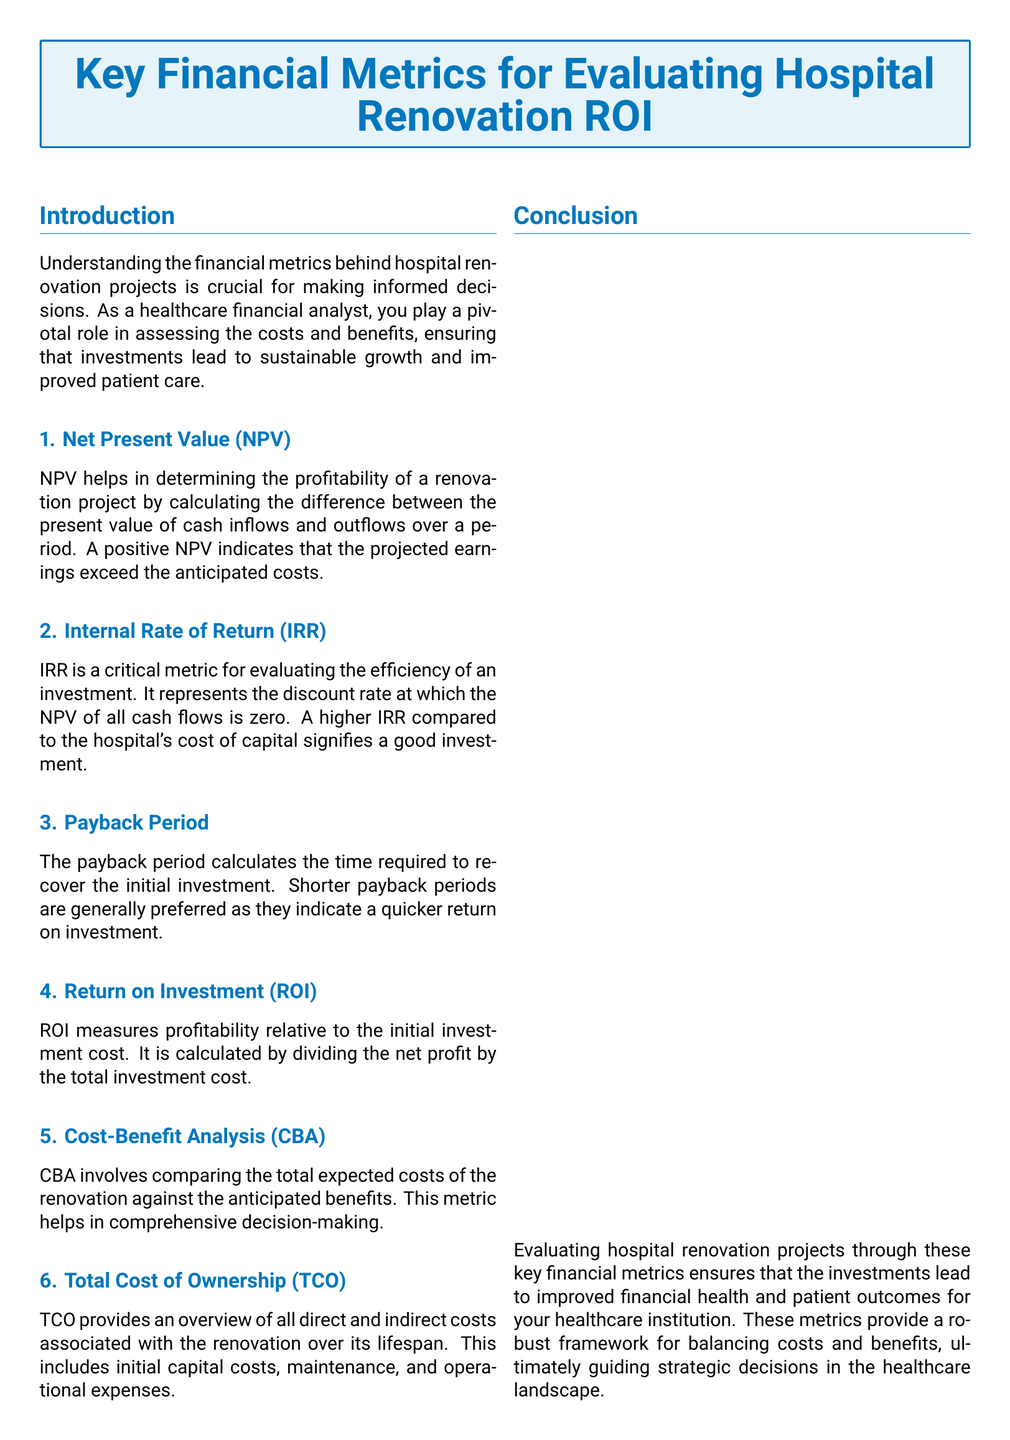What is the primary focus of the document? The document focuses on key financial metrics for evaluating hospital renovation ROI, highlighting their importance for informed decision-making.
Answer: Key financial metrics for evaluating hospital renovation ROI What does NPV stand for? NPV is an abbreviation that refers to Net Present Value, a metric discussed in the document.
Answer: Net Present Value What is the importance of a positive NPV? A positive NPV indicates that the projected earnings exceed the anticipated costs, which is essential for project profitability.
Answer: Projected earnings exceed costs What is the IRR used for? The IRR represents the discount rate at which the NPV of all cash flows is zero, serving as a measure of investment efficiency.
Answer: Measure of investment efficiency How is ROI calculated? ROI is calculated by dividing the net profit by the total investment cost, providing a measure of profitability relative to the investment.
Answer: Net profit divided by total investment cost What does CBA stand for? CBA is an abbreviation for Cost-Benefit Analysis, which compares total expected costs against anticipated benefits.
Answer: Cost-Benefit Analysis Which financial metric provides an overview of all direct and indirect costs? The Total Cost of Ownership (TCO) gives a comprehensive view of all costs associated with the renovation over its lifespan.
Answer: Total Cost of Ownership What is preferred regarding the payback period? Shorter payback periods are preferred, as they indicate a quicker return on investment.
Answer: Shorter payback periods Who is the contact for further financial insights? The document states that the contact person for further insights is [Your Name], a Healthcare Financial Analyst.
Answer: [Your Name] 